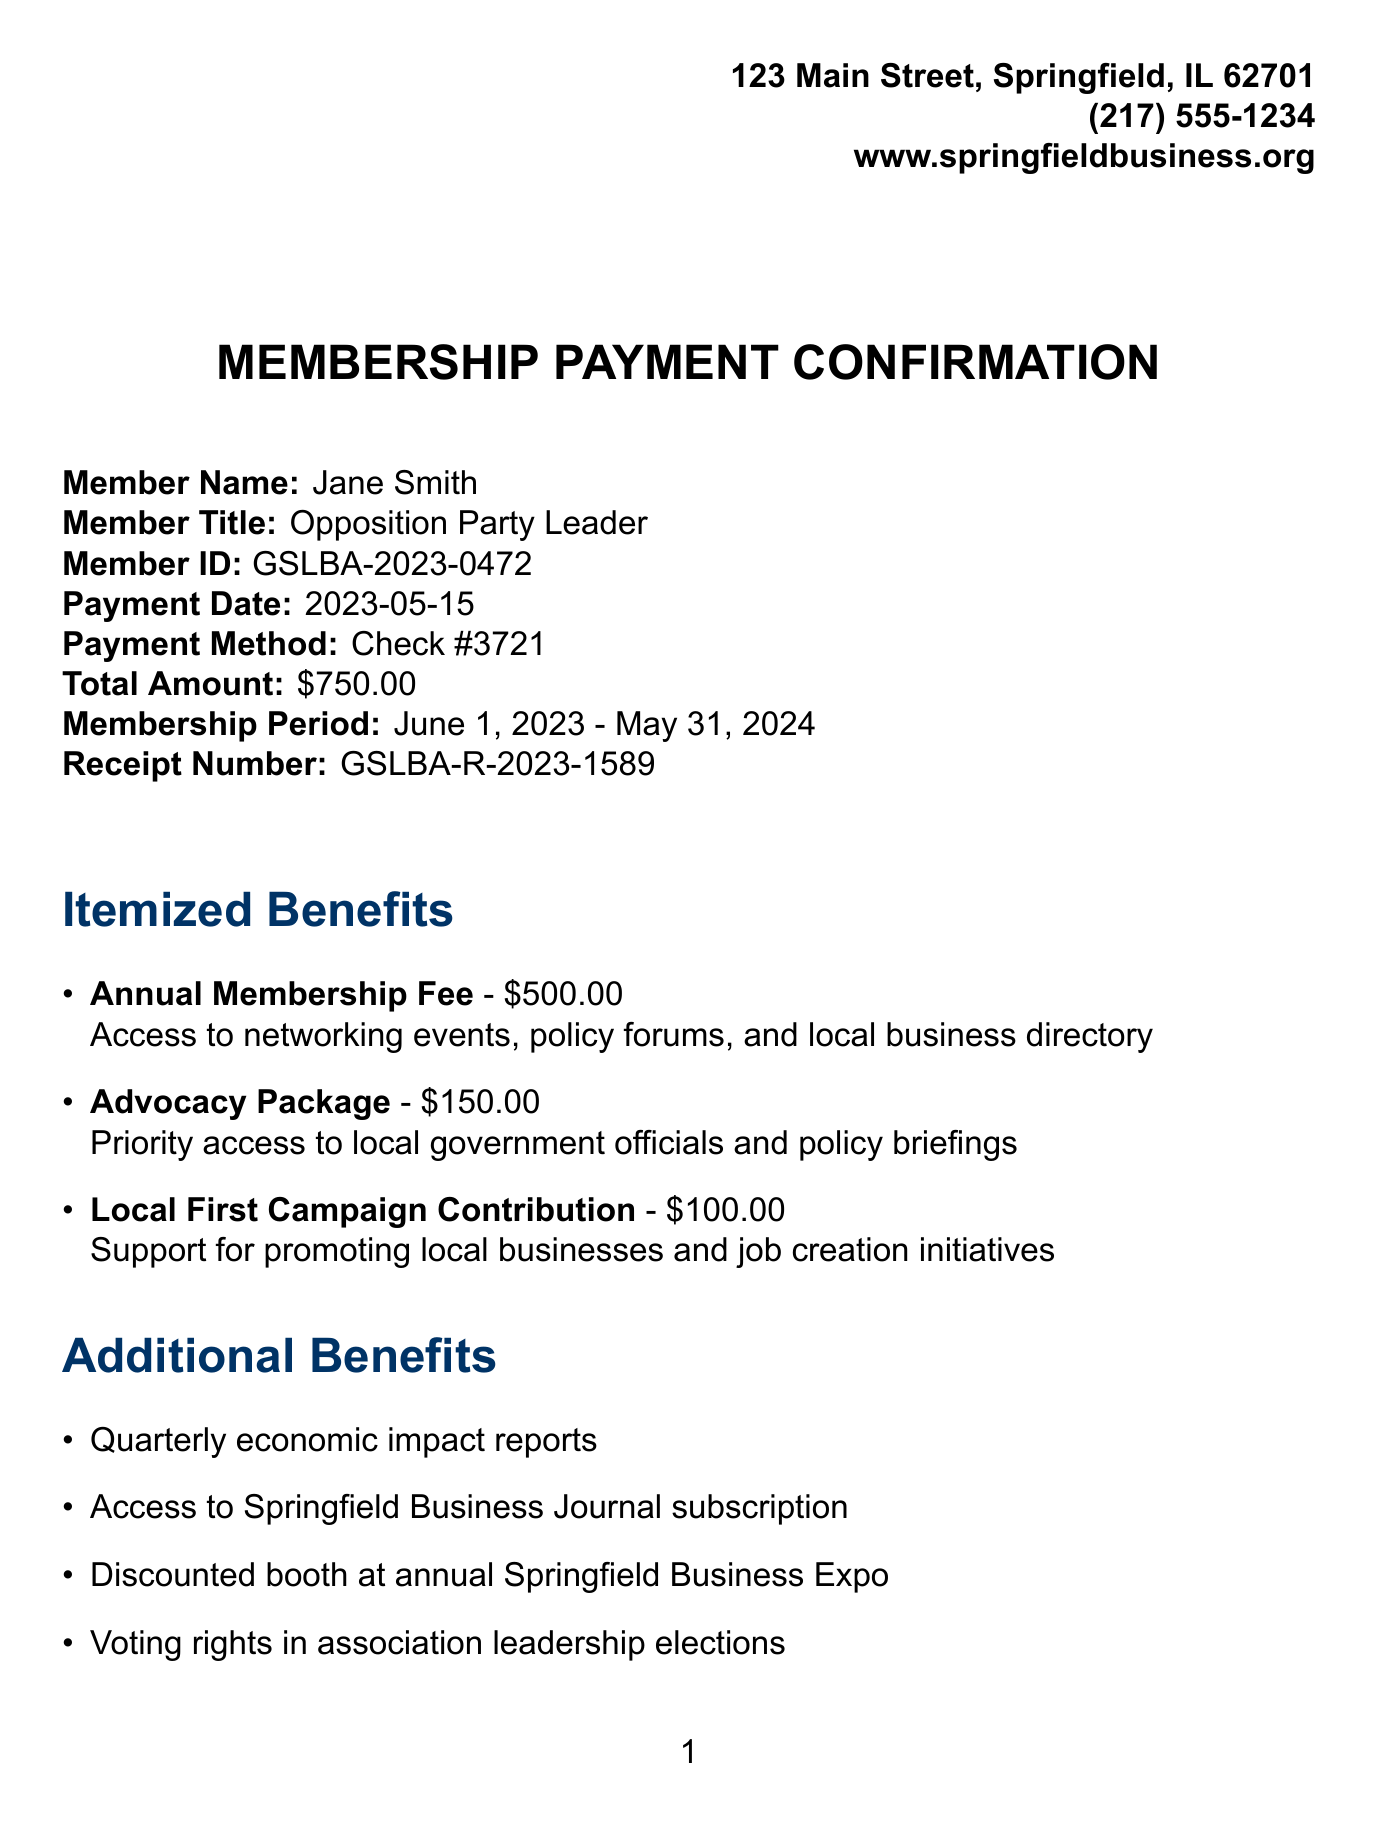What is the organization name? The organization name is listed at the top of the document, identifying the local business association.
Answer: Greater Springfield Local Business Association What is the total amount paid? The total amount is specified in the payment section, indicating how much was paid for the membership.
Answer: $750.00 When does the membership period start? The membership period is mentioned in the document and indicates when the membership begins.
Answer: June 1, 2023 What is the receipt number? The receipt number is clearly stated to track the payment for this membership.
Answer: GSLBA-R-2023-1589 What benefit has the highest amount? The itemized benefits section lists the amounts for each benefit, allowing us to identify the most expensive one.
Answer: Annual Membership Fee What is one of the upcoming events? The document provides a list of upcoming events, each with a date and venue.
Answer: Local Labor Market Symposium How long is the membership valid? The document mentions the start and end date of the membership, indicating its duration.
Answer: One year What payment method was used? The payment method is detailed in the payment section, indicating how the payment was made.
Answer: Check #3721 What is included in the additional benefits? The document lists various additional benefits, showcasing extras that come with the membership.
Answer: Quarterly economic impact reports 